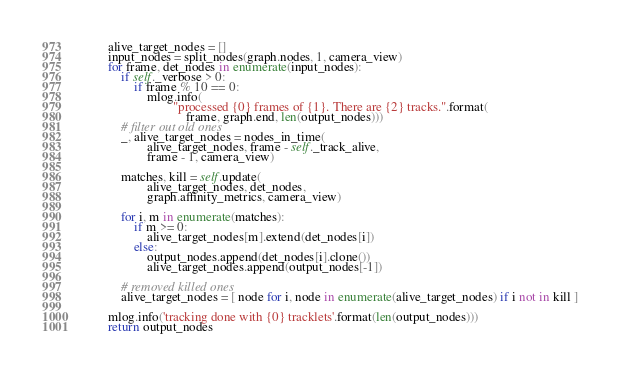Convert code to text. <code><loc_0><loc_0><loc_500><loc_500><_Python_>        alive_target_nodes = []
        input_nodes = split_nodes(graph.nodes, 1, camera_view)
        for frame, det_nodes in enumerate(input_nodes):
            if self._verbose > 0:
                if frame % 10 == 0:
                    mlog.info(
                            "processed {0} frames of {1}. There are {2} tracks.".format(
                                frame, graph.end, len(output_nodes)))
            # filter out old ones
            _, alive_target_nodes = nodes_in_time(
                    alive_target_nodes, frame - self._track_alive, 
                    frame - 1, camera_view)

            matches, kill = self.update(
                    alive_target_nodes, det_nodes,
                    graph.affinity_metrics, camera_view)

            for i, m in enumerate(matches):
                if m >= 0:
                    alive_target_nodes[m].extend(det_nodes[i])
                else:
                    output_nodes.append(det_nodes[i].clone())
                    alive_target_nodes.append(output_nodes[-1])
        
            # removed killed ones
            alive_target_nodes = [ node for i, node in enumerate(alive_target_nodes) if i not in kill ]

        mlog.info('tracking done with {0} tracklets'.format(len(output_nodes)))
        return output_nodes
</code> 